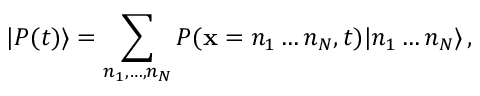Convert formula to latex. <formula><loc_0><loc_0><loc_500><loc_500>| P ( t ) \rangle = \sum _ { n _ { 1 } , \dots , n _ { N } } P ( x = n _ { 1 } \dots n _ { N } , t ) | n _ { 1 } \dots n _ { N } \rangle \, ,</formula> 